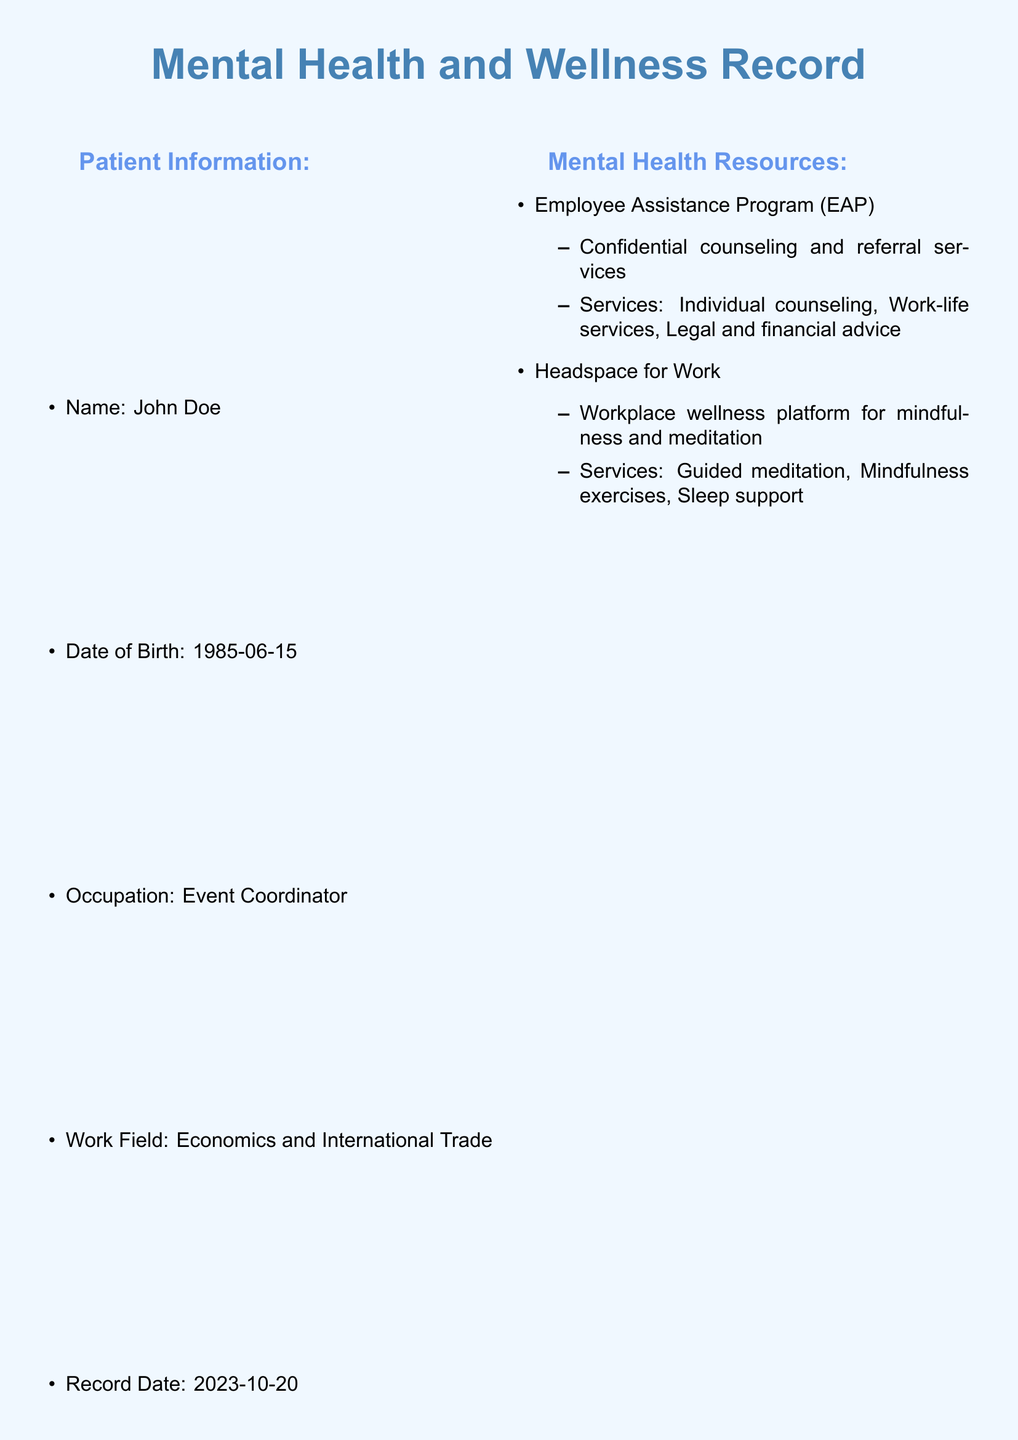What is the patient's name? The patient's name is specified in the patient information section of the document.
Answer: John Doe What is the date of birth of the patient? The patient's date of birth is listed in the patient information section.
Answer: 1985-06-15 What is the frequency of Yoga Sessions? The document states the frequency of yoga sessions in the stress relief activities section.
Answer: Weekly Which organization provides Cognitive Behavioral Therapy? The organization providing CBT is mentioned in the counseling services section.
Answer: BetterHelp What is the duration of the Stress Management Workshop? The workshop duration is provided in the wellness workshops section of the document.
Answer: 2 hours How often are Time Management Skills workshops held? The frequency of the Time Management Skills workshop is detailed in the wellness workshops section.
Answer: Bi-annually What type of counseling is offered through CalmWorks? The type of counseling provided by CalmWorks is specified in the counseling services section.
Answer: On-Site Counseling How many stress relief activities are listed? The total count of stress relief activities can be found by counting the items listed in that section.
Answer: 2 